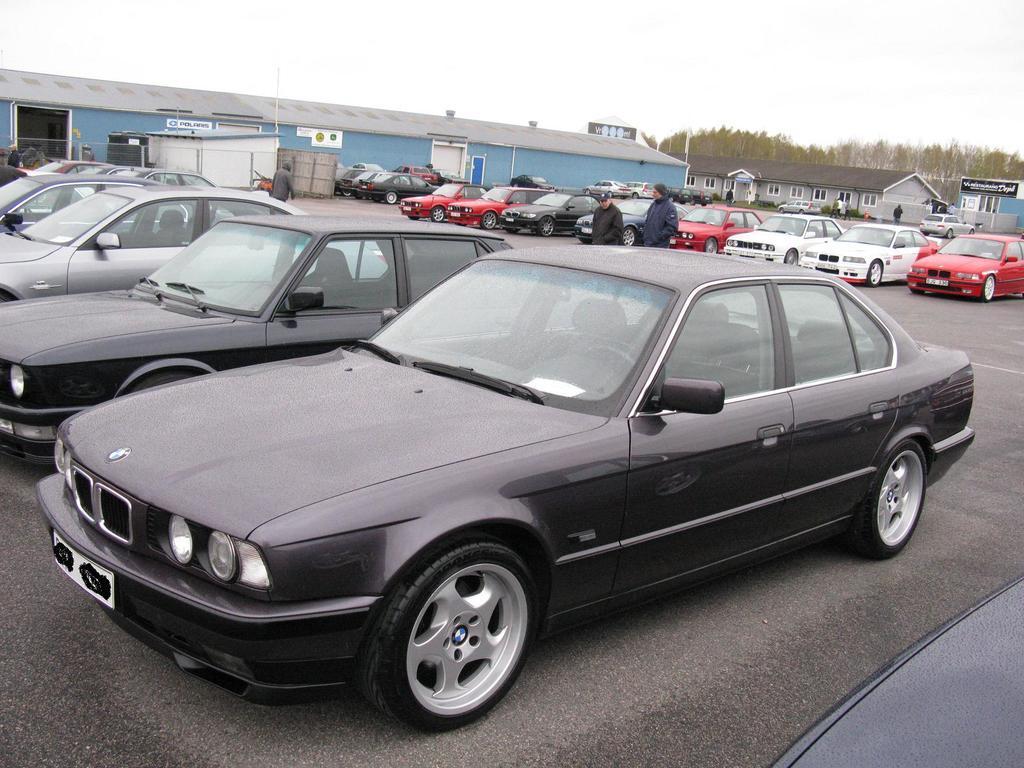Describe this image in one or two sentences. In the image in the center we can see few vehicles were parking. And we can see few people were standing. In the background we can see the sky,clouds,trees,plants,sign boards,buildings etc. 